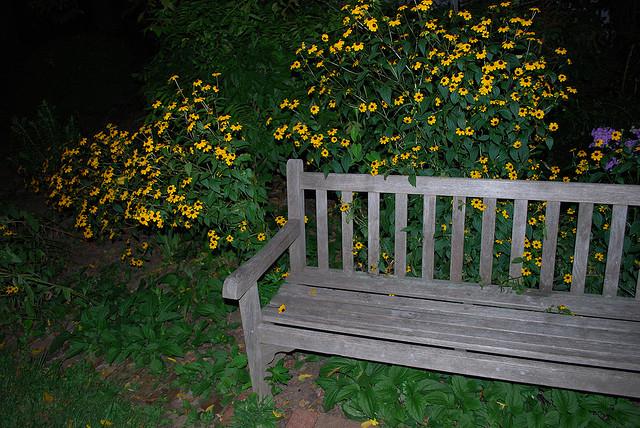What is on the bench?
Write a very short answer. Nothing. What number of boards is the bench made from?
Quick response, please. 10. What kind of flowers on in the top on the left?
Short answer required. Daisies. Is the plant trying to hug the bench?
Quick response, please. No. What is the primary color of these flowers?
Short answer required. Yellow. What time of day is it?
Short answer required. Night. 